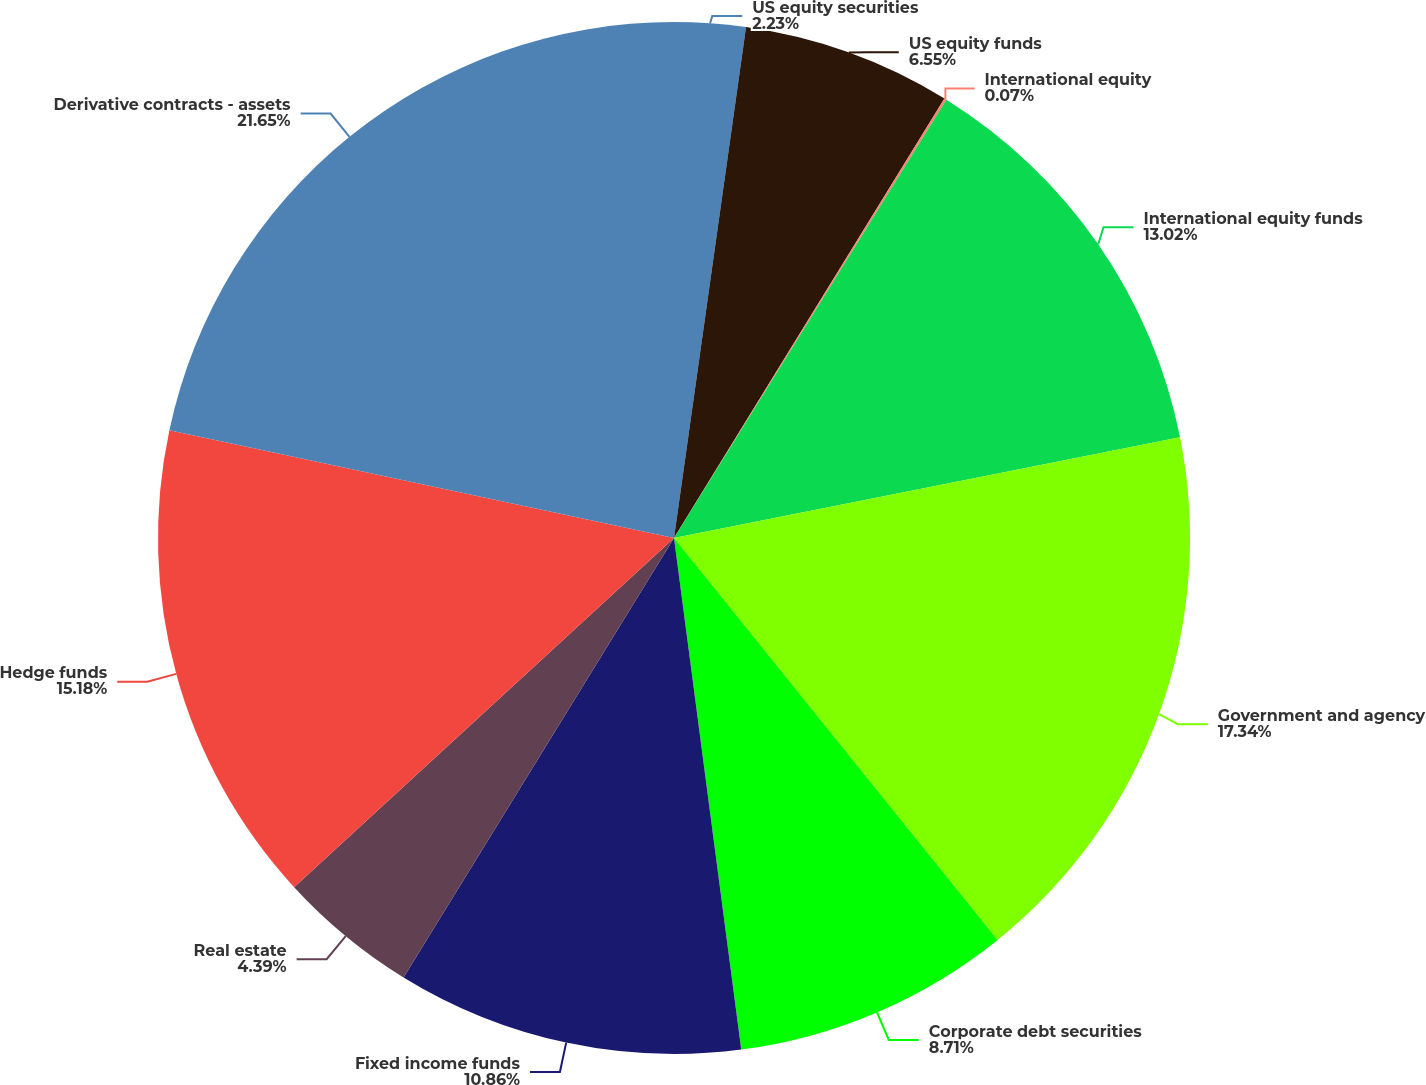Convert chart. <chart><loc_0><loc_0><loc_500><loc_500><pie_chart><fcel>US equity securities<fcel>US equity funds<fcel>International equity<fcel>International equity funds<fcel>Government and agency<fcel>Corporate debt securities<fcel>Fixed income funds<fcel>Real estate<fcel>Hedge funds<fcel>Derivative contracts - assets<nl><fcel>2.23%<fcel>6.55%<fcel>0.07%<fcel>13.02%<fcel>17.34%<fcel>8.71%<fcel>10.86%<fcel>4.39%<fcel>15.18%<fcel>21.65%<nl></chart> 